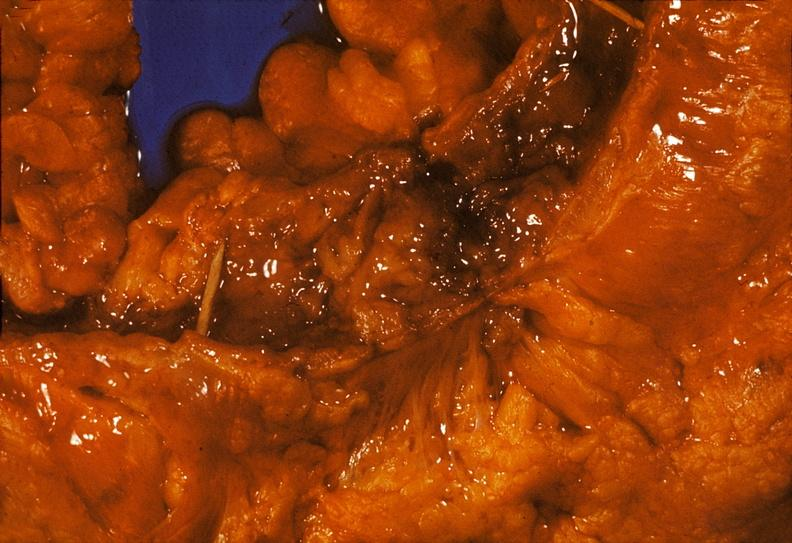does this image show colon, chronic ulcerative colitis, pseudopolyps?
Answer the question using a single word or phrase. Yes 